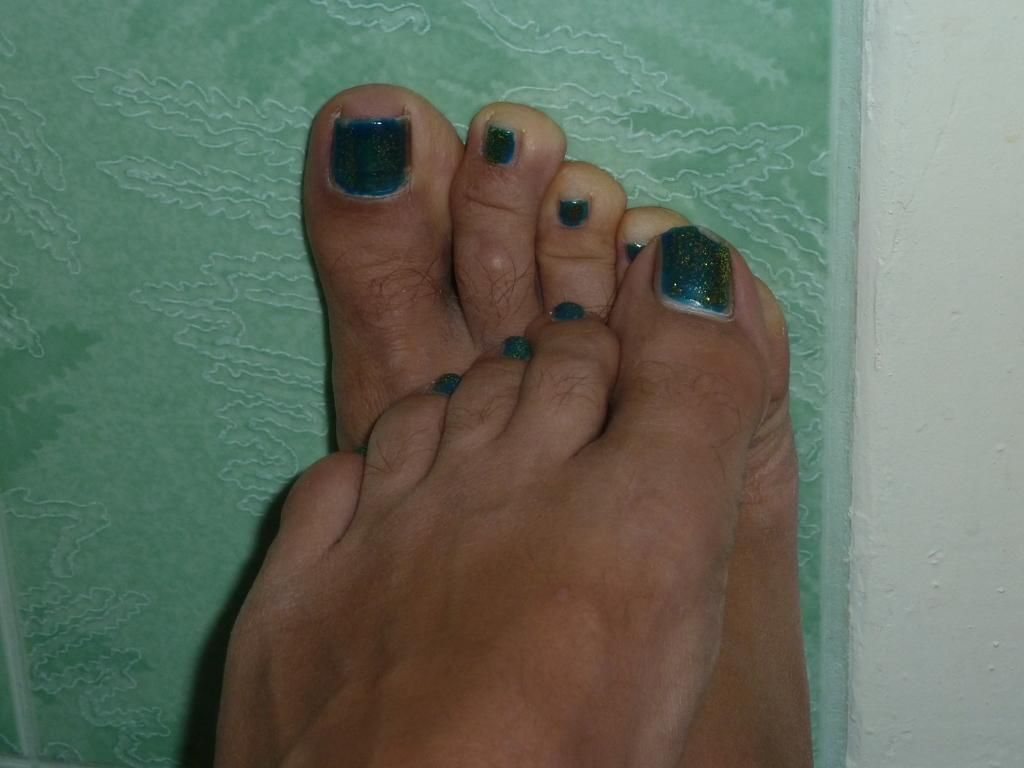What body part is visible in the image? There are foot fingers in the image. What is the appearance of the foot fingers' nails? The foot fingers have green nail polish. What color is predominant in the background of the image? The background of the image has a green color. What type of food is being eaten by the mouth in the image? There is no mouth present in the image; it features foot fingers with green nail polish. What is the value of the grass in the image? There is no grass present in the image. 